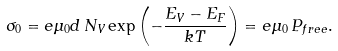Convert formula to latex. <formula><loc_0><loc_0><loc_500><loc_500>\sigma _ { 0 } = e \mu _ { 0 } d \, N _ { V } \exp \left ( - \frac { E _ { V } - E _ { F } } { k T } \right ) = e \mu _ { 0 } \, P _ { f r e e } .</formula> 